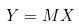<formula> <loc_0><loc_0><loc_500><loc_500>Y = M X</formula> 